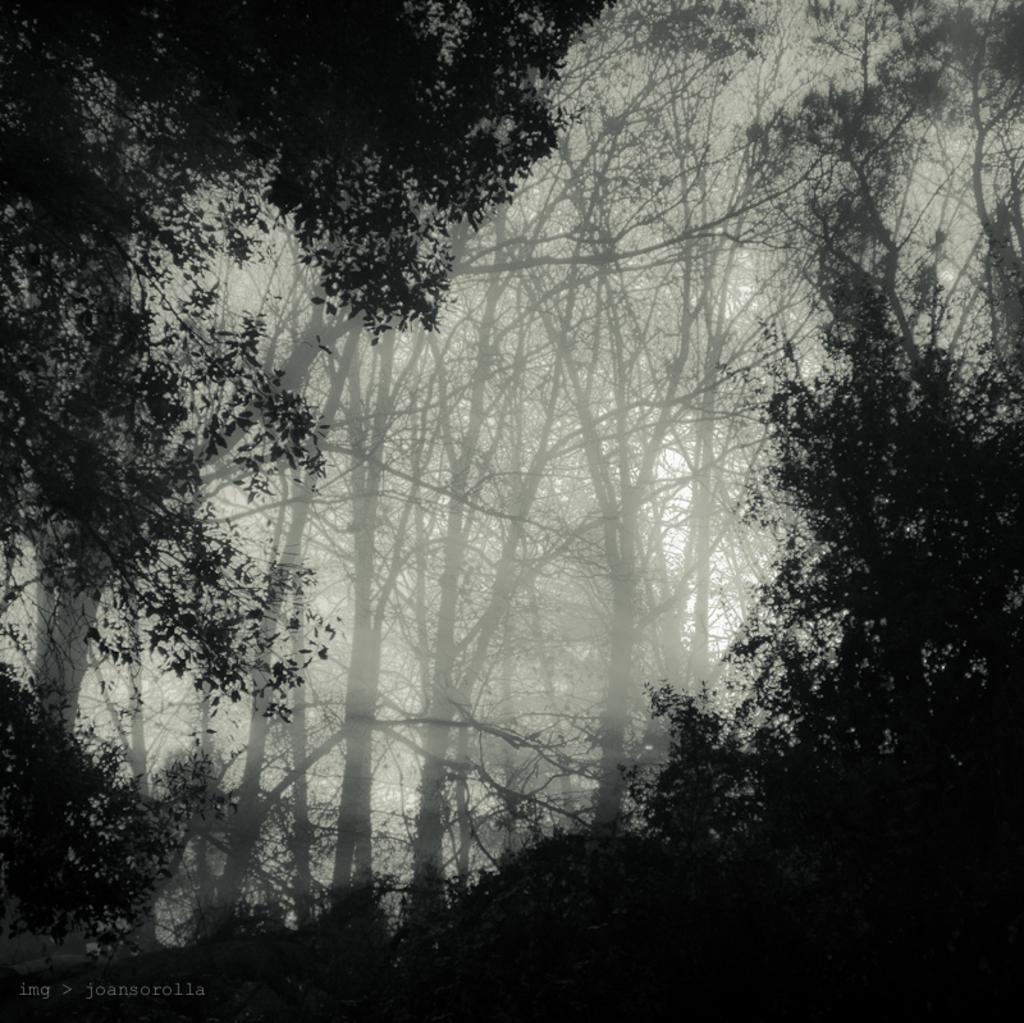What is the primary feature of the image? The primary feature of the image is the many trees. What can be observed around the trees? The trees are surrounded by something. What color is the background of the image? The background of the image is white. What type of muscle can be seen flexing in the image? There is no muscle present in the image; it features many trees surrounded by something with a white background. 